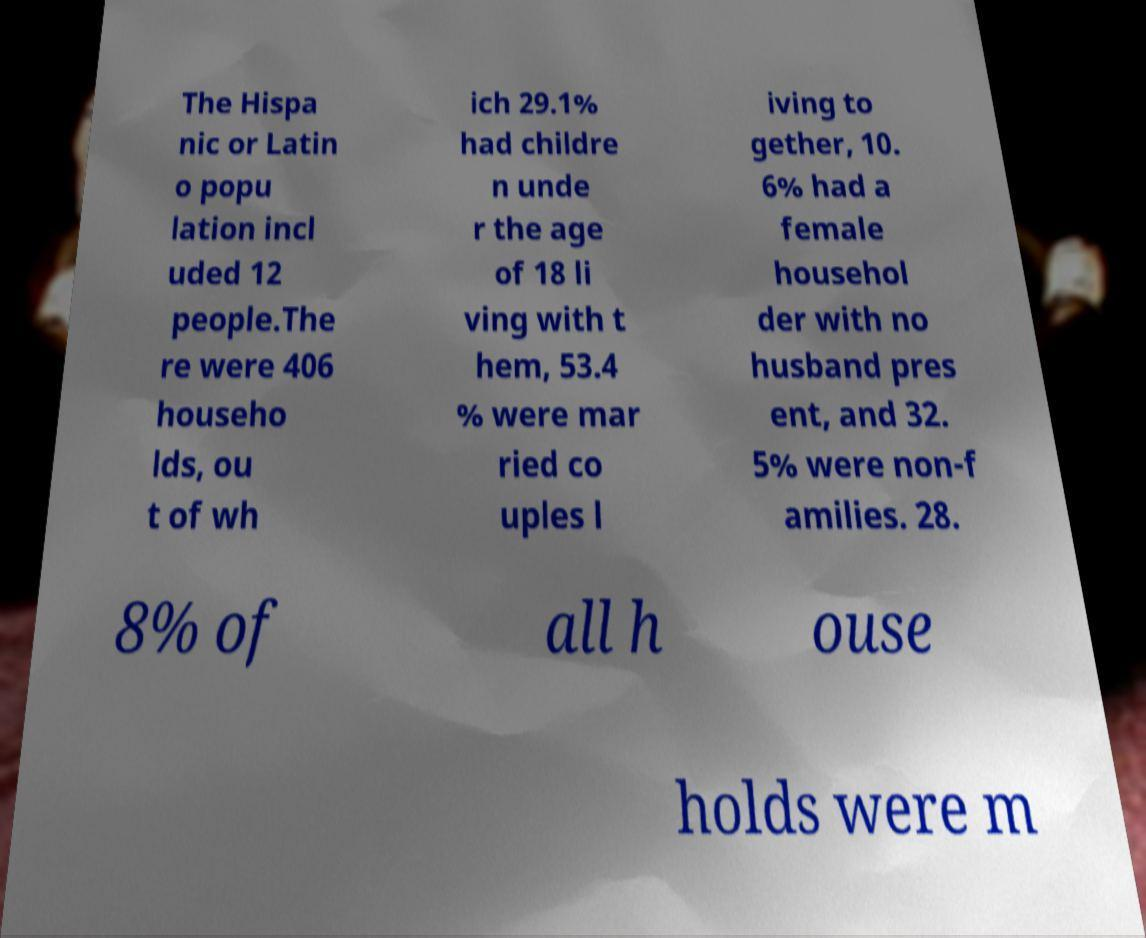Can you accurately transcribe the text from the provided image for me? The Hispa nic or Latin o popu lation incl uded 12 people.The re were 406 househo lds, ou t of wh ich 29.1% had childre n unde r the age of 18 li ving with t hem, 53.4 % were mar ried co uples l iving to gether, 10. 6% had a female househol der with no husband pres ent, and 32. 5% were non-f amilies. 28. 8% of all h ouse holds were m 